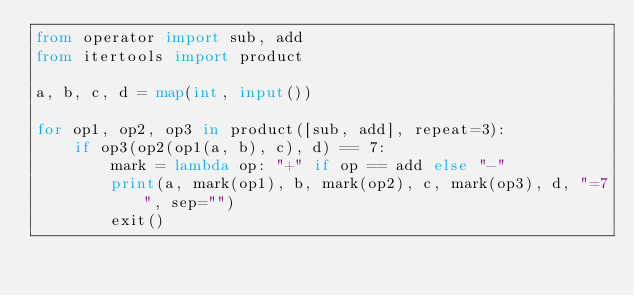<code> <loc_0><loc_0><loc_500><loc_500><_Python_>from operator import sub, add
from itertools import product

a, b, c, d = map(int, input())

for op1, op2, op3 in product([sub, add], repeat=3):
    if op3(op2(op1(a, b), c), d) == 7:
        mark = lambda op: "+" if op == add else "-" 
        print(a, mark(op1), b, mark(op2), c, mark(op3), d, "=7", sep="")
        exit()</code> 